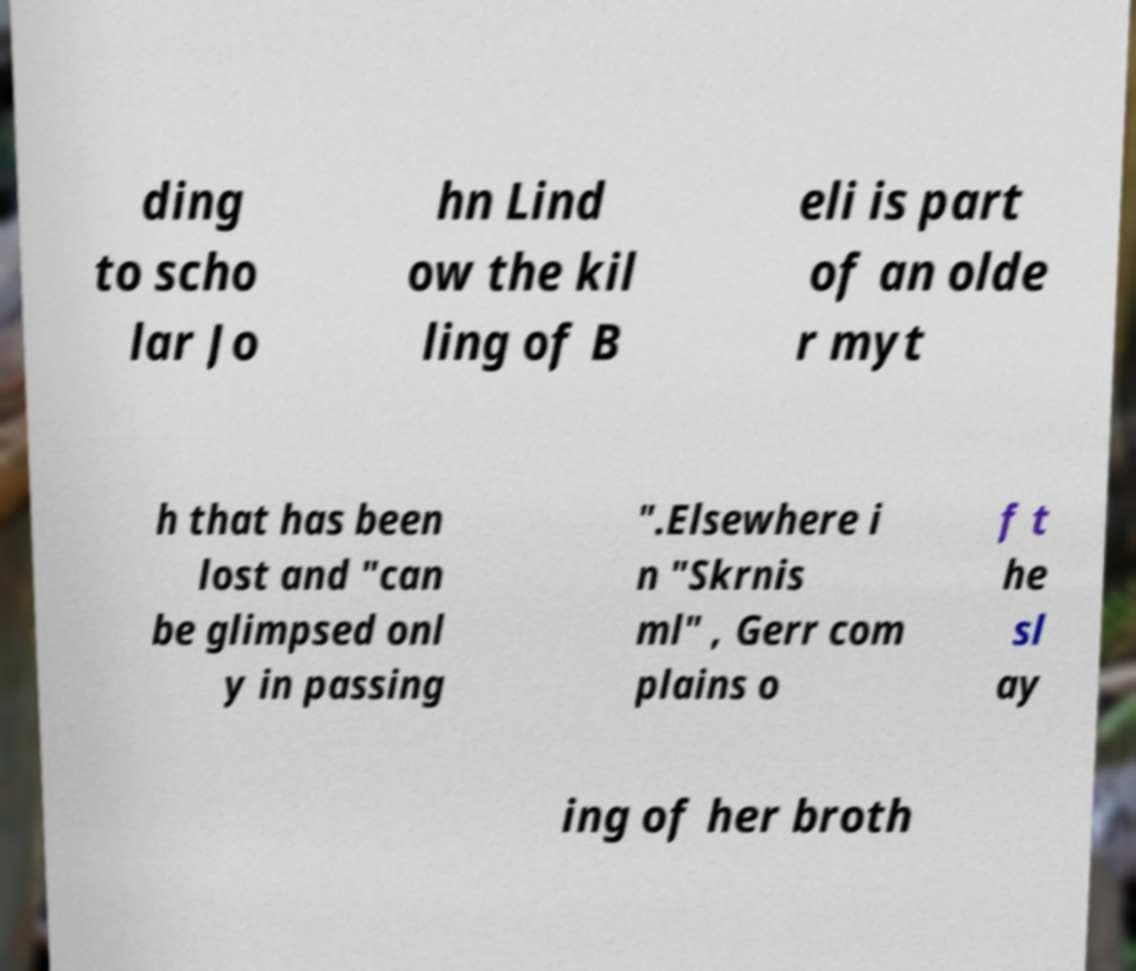Could you assist in decoding the text presented in this image and type it out clearly? ding to scho lar Jo hn Lind ow the kil ling of B eli is part of an olde r myt h that has been lost and "can be glimpsed onl y in passing ".Elsewhere i n "Skrnis ml" , Gerr com plains o f t he sl ay ing of her broth 